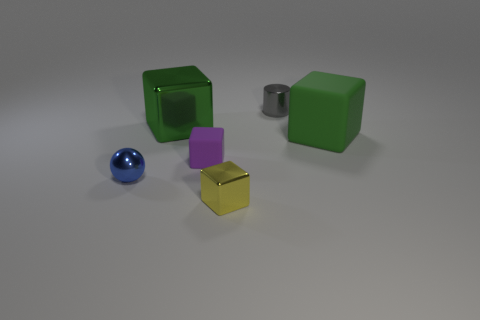Can you describe the overall arrangement and color scheme of the objects presented? Certainly! The image displays a collection of geometric objects arranged on a flat surface. There are two larger green cubes, a smaller purple cube, a small yellow cube with a reflective surface, a shiny cylindrical object, and a small sphere with a reflective blue surface. This assembly of objects seems to embrace both symmetry in shapes—reflected by the cubes—and a variety of colors that visually stand out against the neutral background. 